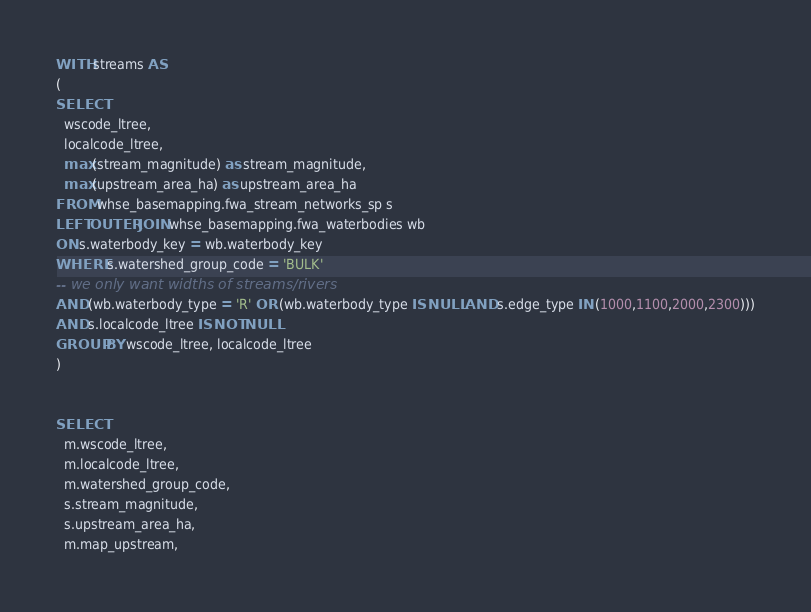<code> <loc_0><loc_0><loc_500><loc_500><_SQL_>WITH streams AS
(
SELECT
  wscode_ltree,
  localcode_ltree,
  max(stream_magnitude) as stream_magnitude,
  max(upstream_area_ha) as upstream_area_ha
FROM whse_basemapping.fwa_stream_networks_sp s
LEFT OUTER JOIN whse_basemapping.fwa_waterbodies wb
ON s.waterbody_key = wb.waterbody_key
WHERE s.watershed_group_code = 'BULK'
-- we only want widths of streams/rivers
AND (wb.waterbody_type = 'R' OR (wb.waterbody_type IS NULL AND s.edge_type IN (1000,1100,2000,2300)))
AND s.localcode_ltree IS NOT NULL
GROUP BY wscode_ltree, localcode_ltree
)


SELECT
  m.wscode_ltree,
  m.localcode_ltree,
  m.watershed_group_code,
  s.stream_magnitude,
  s.upstream_area_ha,
  m.map_upstream,</code> 